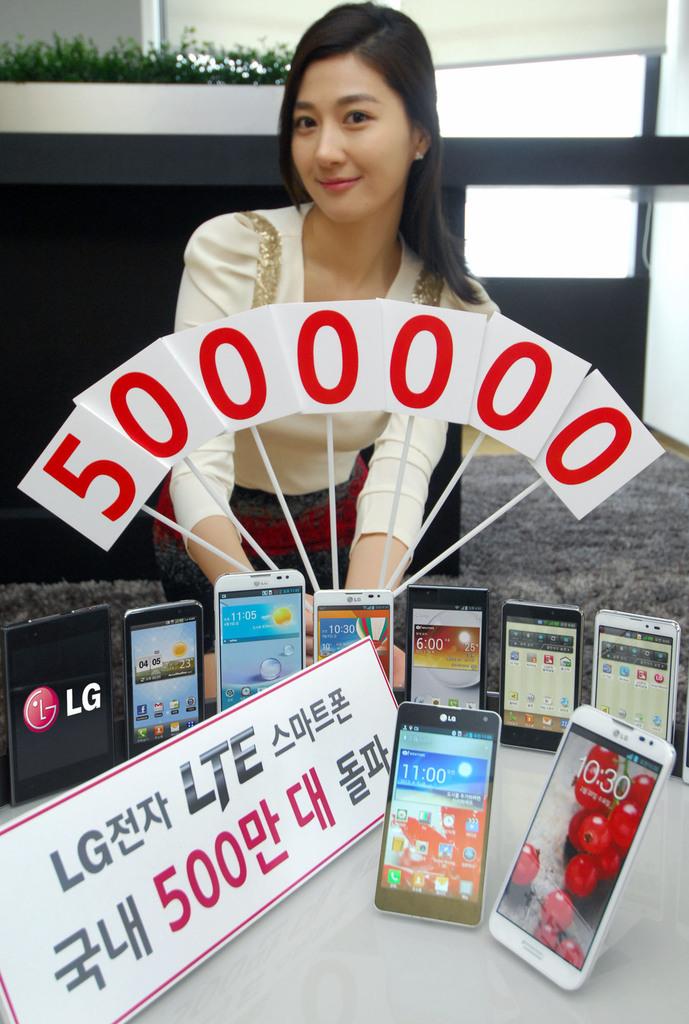What brand of phone is she promoting?
Your response must be concise. Lg. How many "0" are shown in front of the lady?
Give a very brief answer. 6. 